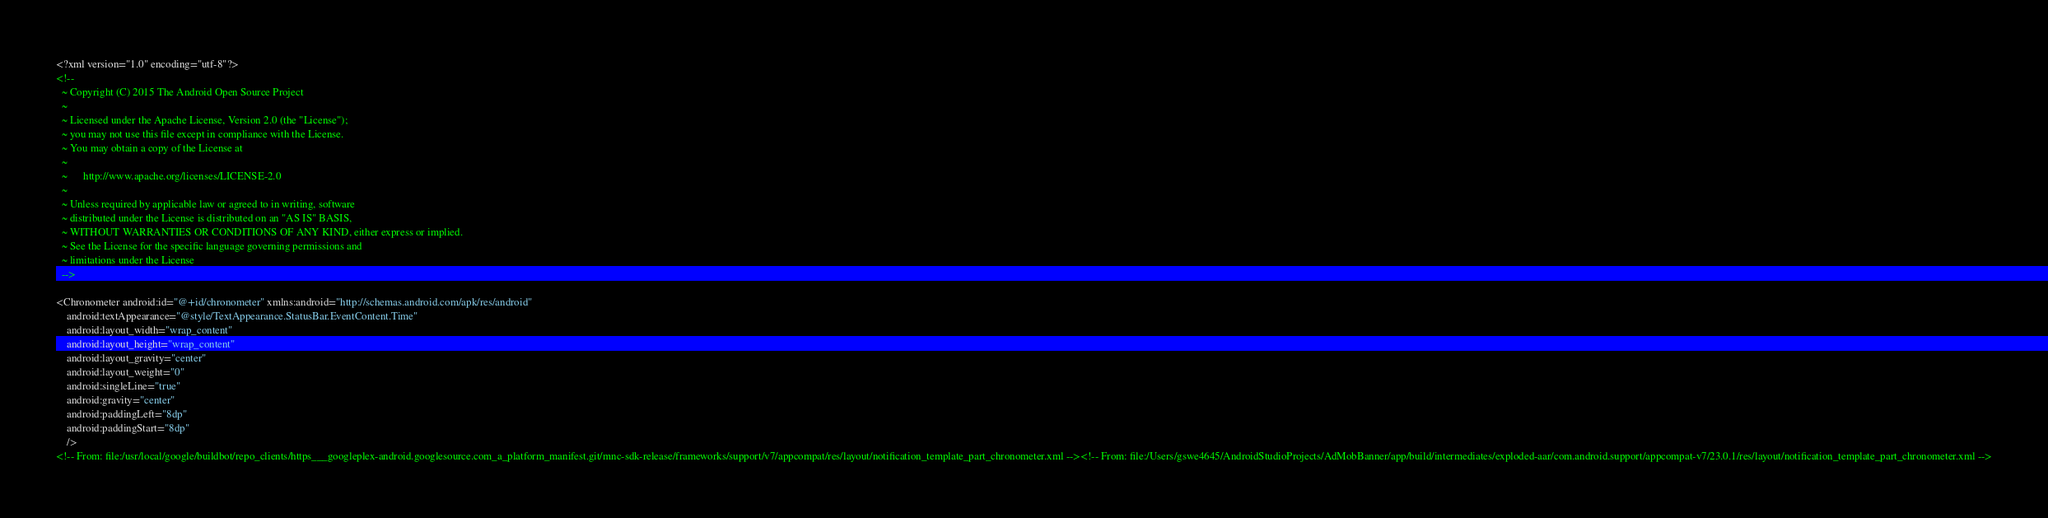<code> <loc_0><loc_0><loc_500><loc_500><_XML_><?xml version="1.0" encoding="utf-8"?>
<!--
  ~ Copyright (C) 2015 The Android Open Source Project
  ~
  ~ Licensed under the Apache License, Version 2.0 (the "License");
  ~ you may not use this file except in compliance with the License.
  ~ You may obtain a copy of the License at
  ~
  ~      http://www.apache.org/licenses/LICENSE-2.0
  ~
  ~ Unless required by applicable law or agreed to in writing, software
  ~ distributed under the License is distributed on an "AS IS" BASIS,
  ~ WITHOUT WARRANTIES OR CONDITIONS OF ANY KIND, either express or implied.
  ~ See the License for the specific language governing permissions and
  ~ limitations under the License
  -->

<Chronometer android:id="@+id/chronometer" xmlns:android="http://schemas.android.com/apk/res/android"
    android:textAppearance="@style/TextAppearance.StatusBar.EventContent.Time"
    android:layout_width="wrap_content"
    android:layout_height="wrap_content"
    android:layout_gravity="center"
    android:layout_weight="0"
    android:singleLine="true"
    android:gravity="center"
    android:paddingLeft="8dp"
    android:paddingStart="8dp"
    />
<!-- From: file:/usr/local/google/buildbot/repo_clients/https___googleplex-android.googlesource.com_a_platform_manifest.git/mnc-sdk-release/frameworks/support/v7/appcompat/res/layout/notification_template_part_chronometer.xml --><!-- From: file:/Users/gswe4645/AndroidStudioProjects/AdMobBanner/app/build/intermediates/exploded-aar/com.android.support/appcompat-v7/23.0.1/res/layout/notification_template_part_chronometer.xml --></code> 